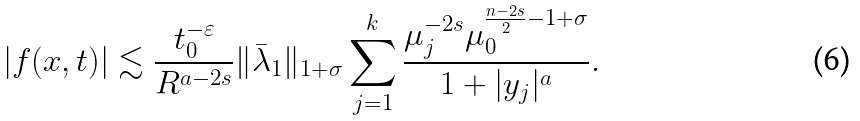Convert formula to latex. <formula><loc_0><loc_0><loc_500><loc_500>\left | f ( x , t ) \right | \lesssim \frac { t _ { 0 } ^ { - \varepsilon } } { R ^ { a - 2 s } } \| \bar { \lambda } _ { 1 } \| _ { 1 + \sigma } \sum _ { j = 1 } ^ { k } \frac { \mu _ { j } ^ { - 2 s } \mu _ { 0 } ^ { \frac { n - 2 s } { 2 } - 1 + \sigma } } { 1 + | y _ { j } | ^ { a } } .</formula> 